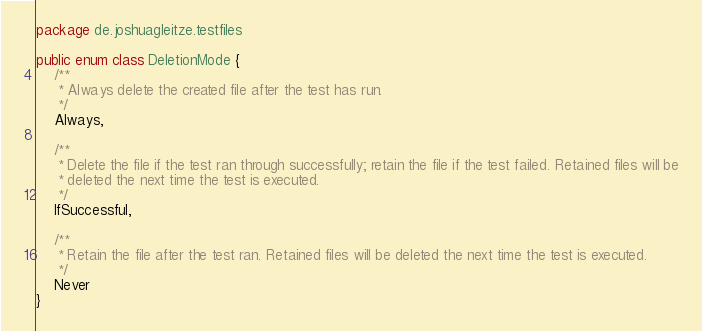<code> <loc_0><loc_0><loc_500><loc_500><_Kotlin_>package de.joshuagleitze.testfiles

public enum class DeletionMode {
	/**
	 * Always delete the created file after the test has run.
	 */
	Always,

	/**
	 * Delete the file if the test ran through successfully; retain the file if the test failed. Retained files will be
	 * deleted the next time the test is executed.
	 */
	IfSuccessful,

	/**
	 * Retain the file after the test ran. Retained files will be deleted the next time the test is executed.
	 */
	Never
}
</code> 